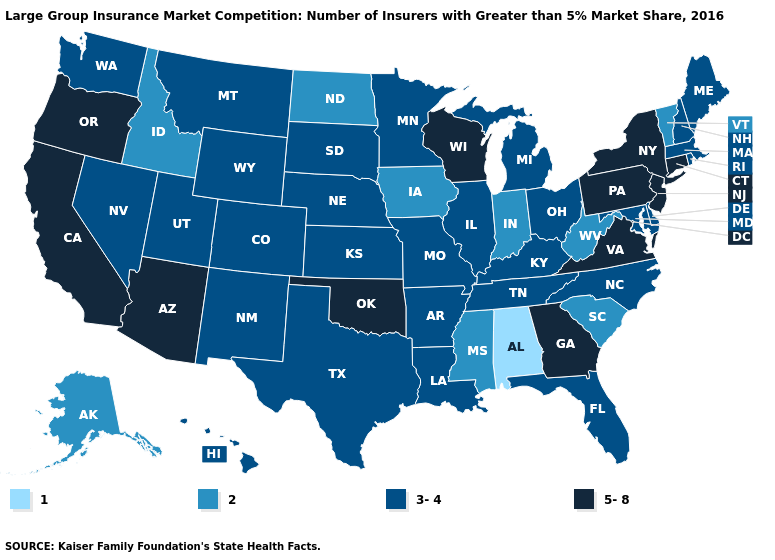What is the lowest value in the South?
Keep it brief. 1. What is the highest value in the Northeast ?
Give a very brief answer. 5-8. What is the highest value in the USA?
Short answer required. 5-8. What is the lowest value in the USA?
Write a very short answer. 1. Name the states that have a value in the range 5-8?
Quick response, please. Arizona, California, Connecticut, Georgia, New Jersey, New York, Oklahoma, Oregon, Pennsylvania, Virginia, Wisconsin. Among the states that border Missouri , which have the highest value?
Answer briefly. Oklahoma. Does Missouri have the lowest value in the MidWest?
Short answer required. No. What is the value of Virginia?
Concise answer only. 5-8. Name the states that have a value in the range 2?
Give a very brief answer. Alaska, Idaho, Indiana, Iowa, Mississippi, North Dakota, South Carolina, Vermont, West Virginia. What is the lowest value in the USA?
Keep it brief. 1. What is the value of Wyoming?
Write a very short answer. 3-4. What is the value of Kansas?
Short answer required. 3-4. What is the lowest value in the USA?
Write a very short answer. 1. Is the legend a continuous bar?
Give a very brief answer. No. Among the states that border Tennessee , does Alabama have the lowest value?
Quick response, please. Yes. 